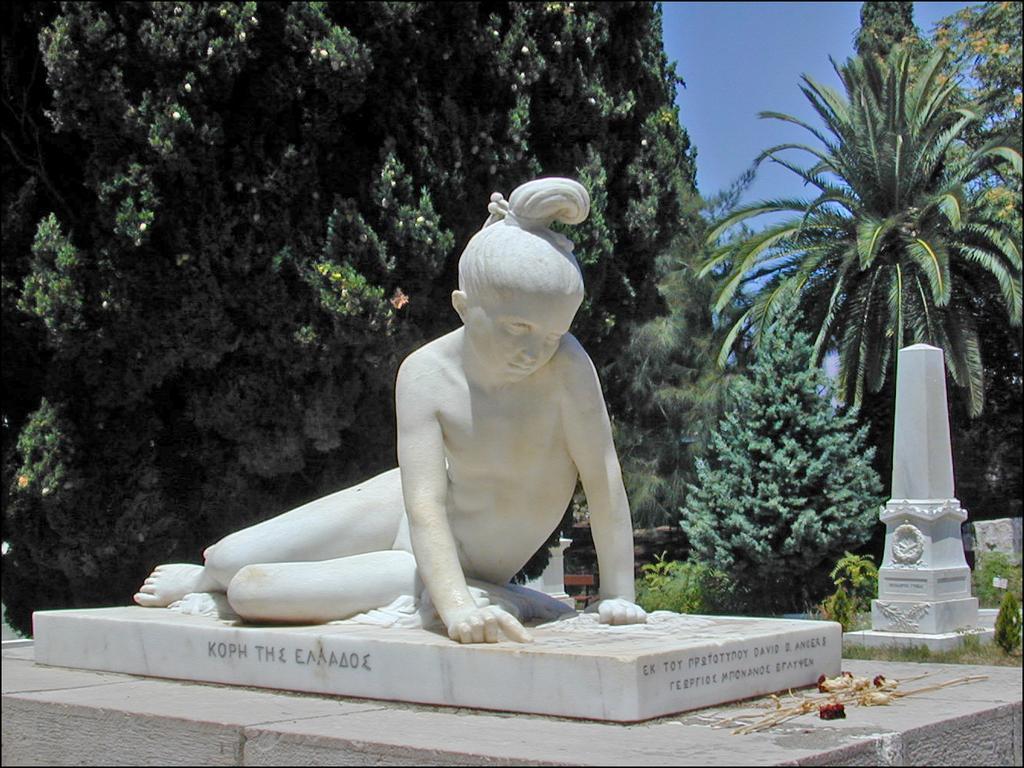Please provide a concise description of this image. In the image,there is a white sculpture and behind the sculpture there are a lot of trees and plants,in the background there is a sky. 